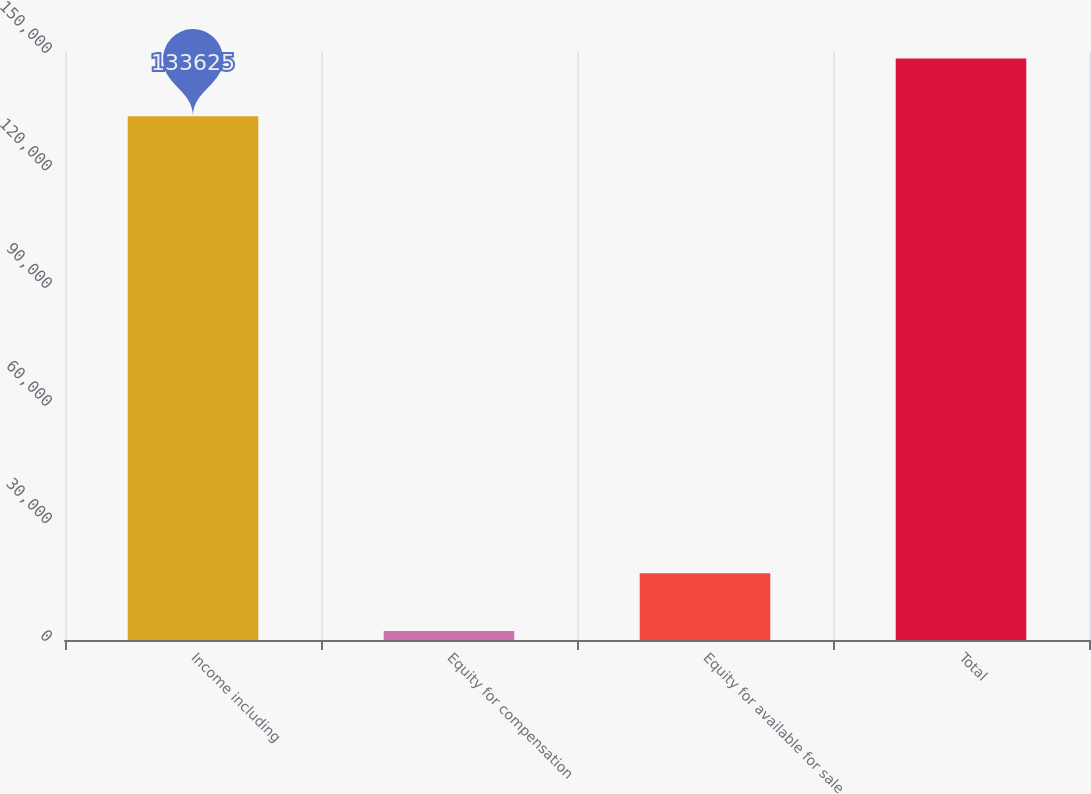<chart> <loc_0><loc_0><loc_500><loc_500><bar_chart><fcel>Income including<fcel>Equity for compensation<fcel>Equity for available for sale<fcel>Total<nl><fcel>133625<fcel>2280<fcel>17020<fcel>148365<nl></chart> 